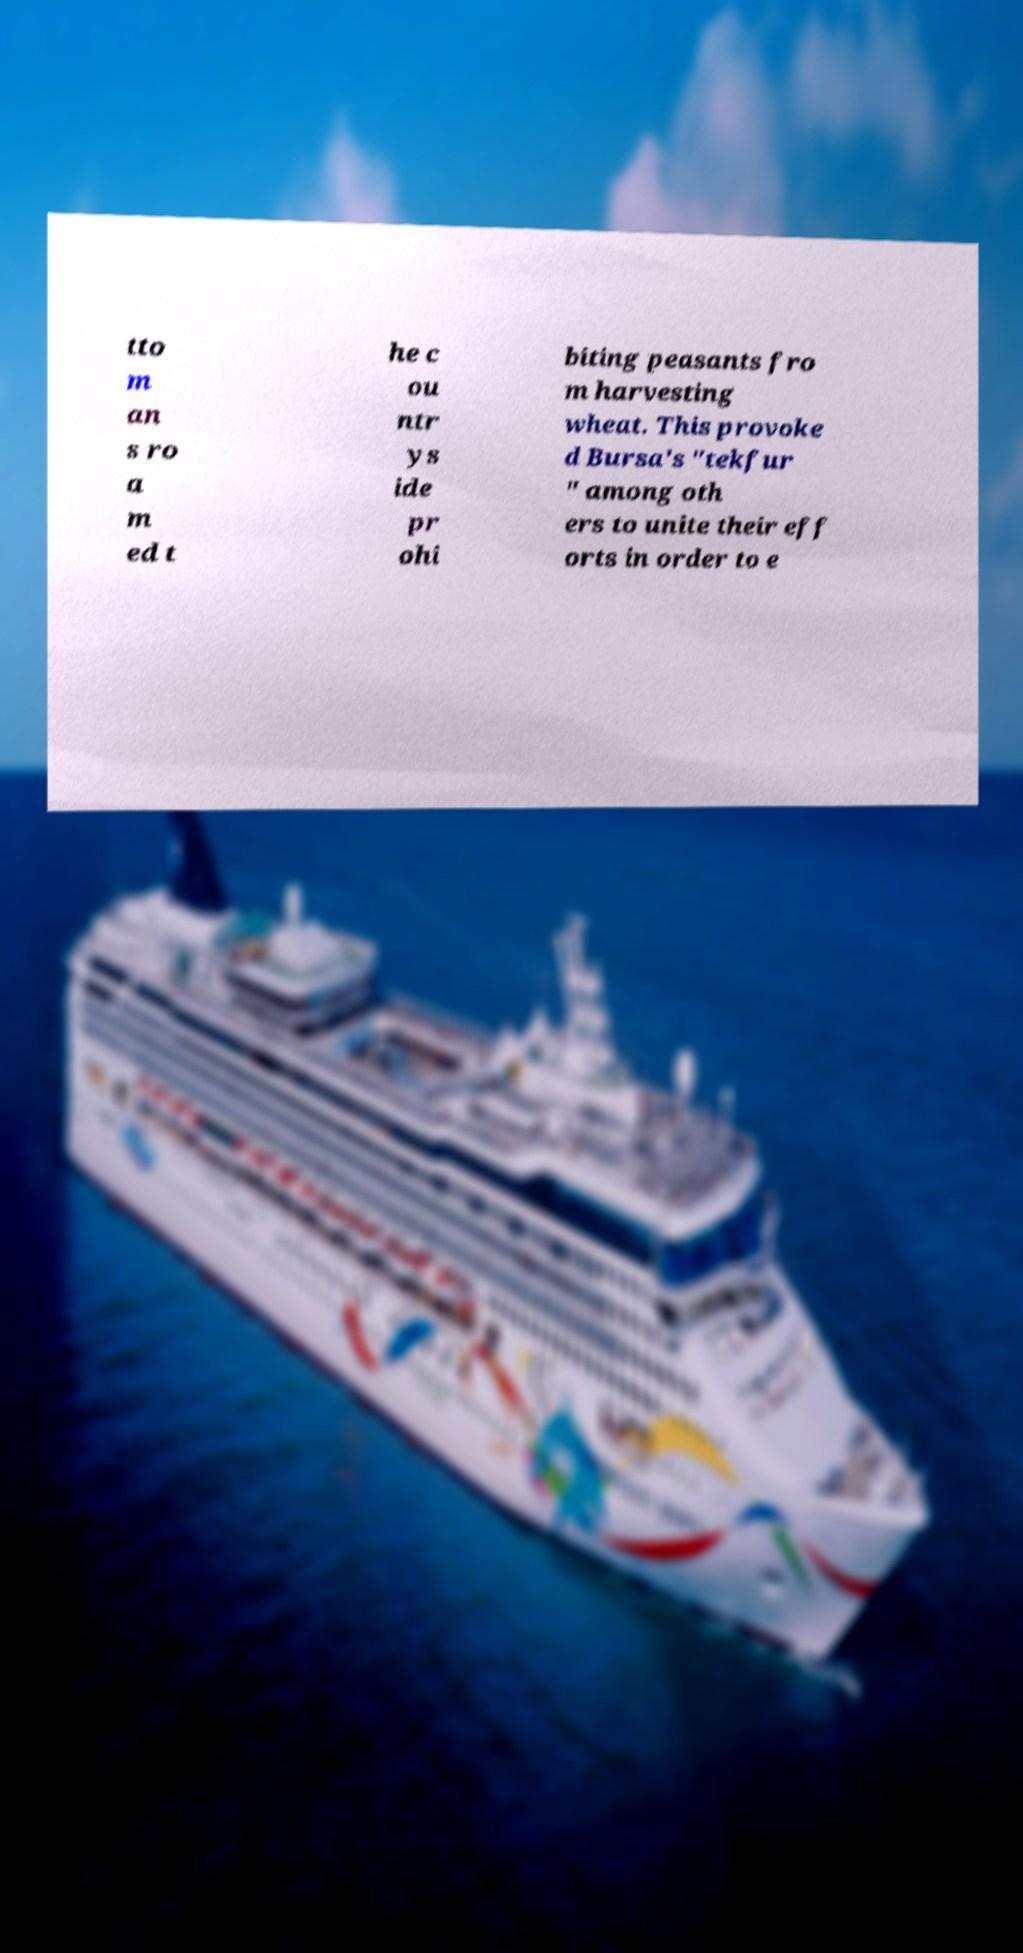Please identify and transcribe the text found in this image. tto m an s ro a m ed t he c ou ntr ys ide pr ohi biting peasants fro m harvesting wheat. This provoke d Bursa's "tekfur " among oth ers to unite their eff orts in order to e 